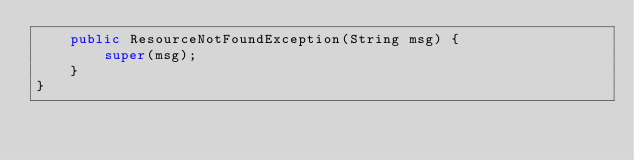<code> <loc_0><loc_0><loc_500><loc_500><_Java_>    public ResourceNotFoundException(String msg) {
        super(msg);
    }
}</code> 